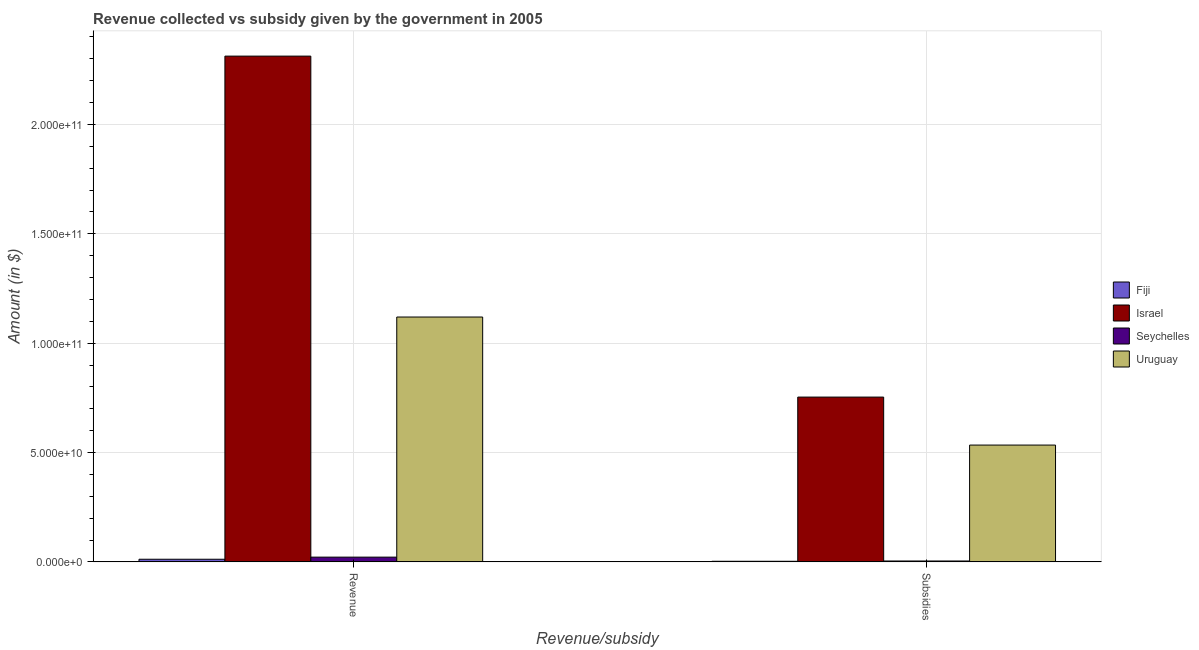Are the number of bars on each tick of the X-axis equal?
Offer a terse response. Yes. How many bars are there on the 1st tick from the left?
Make the answer very short. 4. How many bars are there on the 1st tick from the right?
Keep it short and to the point. 4. What is the label of the 1st group of bars from the left?
Give a very brief answer. Revenue. What is the amount of revenue collected in Israel?
Offer a terse response. 2.31e+11. Across all countries, what is the maximum amount of subsidies given?
Keep it short and to the point. 7.53e+1. Across all countries, what is the minimum amount of subsidies given?
Offer a terse response. 2.88e+08. In which country was the amount of subsidies given minimum?
Offer a very short reply. Fiji. What is the total amount of subsidies given in the graph?
Offer a very short reply. 1.29e+11. What is the difference between the amount of revenue collected in Fiji and that in Israel?
Your answer should be compact. -2.30e+11. What is the difference between the amount of subsidies given in Fiji and the amount of revenue collected in Uruguay?
Offer a terse response. -1.12e+11. What is the average amount of revenue collected per country?
Your response must be concise. 8.66e+1. What is the difference between the amount of subsidies given and amount of revenue collected in Israel?
Offer a terse response. -1.56e+11. In how many countries, is the amount of revenue collected greater than 60000000000 $?
Provide a succinct answer. 2. What is the ratio of the amount of subsidies given in Israel to that in Uruguay?
Offer a very short reply. 1.41. Is the amount of subsidies given in Seychelles less than that in Fiji?
Offer a very short reply. No. In how many countries, is the amount of subsidies given greater than the average amount of subsidies given taken over all countries?
Give a very brief answer. 2. How many bars are there?
Give a very brief answer. 8. How many countries are there in the graph?
Give a very brief answer. 4. What is the difference between two consecutive major ticks on the Y-axis?
Offer a terse response. 5.00e+1. Are the values on the major ticks of Y-axis written in scientific E-notation?
Your answer should be compact. Yes. Does the graph contain any zero values?
Provide a succinct answer. No. Does the graph contain grids?
Your answer should be compact. Yes. How many legend labels are there?
Keep it short and to the point. 4. What is the title of the graph?
Your answer should be very brief. Revenue collected vs subsidy given by the government in 2005. Does "Europe(developing only)" appear as one of the legend labels in the graph?
Your answer should be very brief. No. What is the label or title of the X-axis?
Give a very brief answer. Revenue/subsidy. What is the label or title of the Y-axis?
Offer a terse response. Amount (in $). What is the Amount (in $) in Fiji in Revenue?
Give a very brief answer. 1.22e+09. What is the Amount (in $) of Israel in Revenue?
Ensure brevity in your answer.  2.31e+11. What is the Amount (in $) in Seychelles in Revenue?
Your answer should be very brief. 2.18e+09. What is the Amount (in $) of Uruguay in Revenue?
Give a very brief answer. 1.12e+11. What is the Amount (in $) of Fiji in Subsidies?
Give a very brief answer. 2.88e+08. What is the Amount (in $) in Israel in Subsidies?
Keep it short and to the point. 7.53e+1. What is the Amount (in $) in Seychelles in Subsidies?
Provide a short and direct response. 4.17e+08. What is the Amount (in $) of Uruguay in Subsidies?
Your answer should be very brief. 5.34e+1. Across all Revenue/subsidy, what is the maximum Amount (in $) in Fiji?
Offer a terse response. 1.22e+09. Across all Revenue/subsidy, what is the maximum Amount (in $) in Israel?
Provide a succinct answer. 2.31e+11. Across all Revenue/subsidy, what is the maximum Amount (in $) in Seychelles?
Give a very brief answer. 2.18e+09. Across all Revenue/subsidy, what is the maximum Amount (in $) in Uruguay?
Keep it short and to the point. 1.12e+11. Across all Revenue/subsidy, what is the minimum Amount (in $) of Fiji?
Your answer should be very brief. 2.88e+08. Across all Revenue/subsidy, what is the minimum Amount (in $) of Israel?
Provide a succinct answer. 7.53e+1. Across all Revenue/subsidy, what is the minimum Amount (in $) in Seychelles?
Provide a succinct answer. 4.17e+08. Across all Revenue/subsidy, what is the minimum Amount (in $) of Uruguay?
Ensure brevity in your answer.  5.34e+1. What is the total Amount (in $) of Fiji in the graph?
Give a very brief answer. 1.50e+09. What is the total Amount (in $) in Israel in the graph?
Offer a terse response. 3.07e+11. What is the total Amount (in $) in Seychelles in the graph?
Your answer should be very brief. 2.60e+09. What is the total Amount (in $) of Uruguay in the graph?
Your response must be concise. 1.65e+11. What is the difference between the Amount (in $) in Fiji in Revenue and that in Subsidies?
Provide a short and direct response. 9.28e+08. What is the difference between the Amount (in $) of Israel in Revenue and that in Subsidies?
Give a very brief answer. 1.56e+11. What is the difference between the Amount (in $) of Seychelles in Revenue and that in Subsidies?
Your answer should be compact. 1.76e+09. What is the difference between the Amount (in $) in Uruguay in Revenue and that in Subsidies?
Ensure brevity in your answer.  5.85e+1. What is the difference between the Amount (in $) of Fiji in Revenue and the Amount (in $) of Israel in Subsidies?
Your answer should be compact. -7.41e+1. What is the difference between the Amount (in $) in Fiji in Revenue and the Amount (in $) in Seychelles in Subsidies?
Give a very brief answer. 7.99e+08. What is the difference between the Amount (in $) of Fiji in Revenue and the Amount (in $) of Uruguay in Subsidies?
Keep it short and to the point. -5.22e+1. What is the difference between the Amount (in $) of Israel in Revenue and the Amount (in $) of Seychelles in Subsidies?
Give a very brief answer. 2.31e+11. What is the difference between the Amount (in $) of Israel in Revenue and the Amount (in $) of Uruguay in Subsidies?
Keep it short and to the point. 1.78e+11. What is the difference between the Amount (in $) in Seychelles in Revenue and the Amount (in $) in Uruguay in Subsidies?
Your response must be concise. -5.12e+1. What is the average Amount (in $) of Fiji per Revenue/subsidy?
Make the answer very short. 7.52e+08. What is the average Amount (in $) of Israel per Revenue/subsidy?
Keep it short and to the point. 1.53e+11. What is the average Amount (in $) of Seychelles per Revenue/subsidy?
Ensure brevity in your answer.  1.30e+09. What is the average Amount (in $) of Uruguay per Revenue/subsidy?
Your response must be concise. 8.27e+1. What is the difference between the Amount (in $) of Fiji and Amount (in $) of Israel in Revenue?
Give a very brief answer. -2.30e+11. What is the difference between the Amount (in $) of Fiji and Amount (in $) of Seychelles in Revenue?
Make the answer very short. -9.63e+08. What is the difference between the Amount (in $) of Fiji and Amount (in $) of Uruguay in Revenue?
Make the answer very short. -1.11e+11. What is the difference between the Amount (in $) of Israel and Amount (in $) of Seychelles in Revenue?
Provide a succinct answer. 2.29e+11. What is the difference between the Amount (in $) of Israel and Amount (in $) of Uruguay in Revenue?
Offer a terse response. 1.19e+11. What is the difference between the Amount (in $) of Seychelles and Amount (in $) of Uruguay in Revenue?
Make the answer very short. -1.10e+11. What is the difference between the Amount (in $) of Fiji and Amount (in $) of Israel in Subsidies?
Your answer should be very brief. -7.51e+1. What is the difference between the Amount (in $) of Fiji and Amount (in $) of Seychelles in Subsidies?
Your answer should be very brief. -1.29e+08. What is the difference between the Amount (in $) of Fiji and Amount (in $) of Uruguay in Subsidies?
Offer a terse response. -5.31e+1. What is the difference between the Amount (in $) in Israel and Amount (in $) in Seychelles in Subsidies?
Provide a short and direct response. 7.49e+1. What is the difference between the Amount (in $) in Israel and Amount (in $) in Uruguay in Subsidies?
Make the answer very short. 2.19e+1. What is the difference between the Amount (in $) in Seychelles and Amount (in $) in Uruguay in Subsidies?
Ensure brevity in your answer.  -5.30e+1. What is the ratio of the Amount (in $) of Fiji in Revenue to that in Subsidies?
Your response must be concise. 4.22. What is the ratio of the Amount (in $) of Israel in Revenue to that in Subsidies?
Provide a short and direct response. 3.07. What is the ratio of the Amount (in $) of Seychelles in Revenue to that in Subsidies?
Give a very brief answer. 5.23. What is the ratio of the Amount (in $) of Uruguay in Revenue to that in Subsidies?
Offer a terse response. 2.1. What is the difference between the highest and the second highest Amount (in $) in Fiji?
Make the answer very short. 9.28e+08. What is the difference between the highest and the second highest Amount (in $) of Israel?
Keep it short and to the point. 1.56e+11. What is the difference between the highest and the second highest Amount (in $) in Seychelles?
Offer a terse response. 1.76e+09. What is the difference between the highest and the second highest Amount (in $) in Uruguay?
Offer a very short reply. 5.85e+1. What is the difference between the highest and the lowest Amount (in $) of Fiji?
Offer a very short reply. 9.28e+08. What is the difference between the highest and the lowest Amount (in $) of Israel?
Your response must be concise. 1.56e+11. What is the difference between the highest and the lowest Amount (in $) of Seychelles?
Keep it short and to the point. 1.76e+09. What is the difference between the highest and the lowest Amount (in $) of Uruguay?
Give a very brief answer. 5.85e+1. 